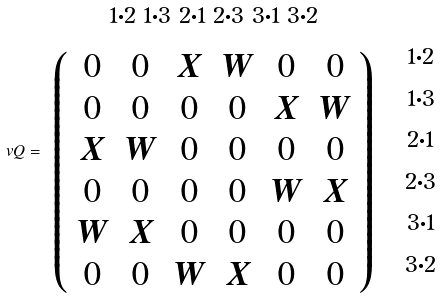Convert formula to latex. <formula><loc_0><loc_0><loc_500><loc_500>\ v Q = \begin{array} { c c } ^ { 1 \cdot 2 } \, ^ { 1 \cdot 3 } \, ^ { 2 \cdot 1 } \, ^ { 2 \cdot 3 } \, ^ { 3 \cdot 1 } \, ^ { 3 \cdot 2 } & \\ \left ( \begin{array} { c c c c c c } 0 & 0 & X & W & 0 & 0 \\ 0 & 0 & 0 & 0 & X & W \\ X & W & 0 & 0 & 0 & 0 \\ 0 & 0 & 0 & 0 & W & X \\ W & X & 0 & 0 & 0 & 0 \\ 0 & 0 & W & X & 0 & 0 \end{array} \right ) & \begin{array} { c } \, ^ { 1 \cdot 2 } \\ \, ^ { 1 \cdot 3 } \\ \, ^ { 2 \cdot 1 } \\ \, ^ { 2 \cdot 3 } \\ \, ^ { 3 \cdot 1 } \\ \, ^ { 3 \cdot 2 } \end{array} \end{array}</formula> 